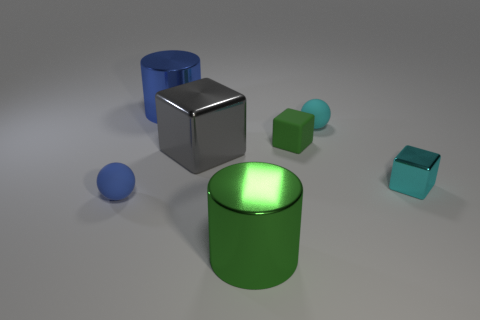Add 1 blue rubber things. How many objects exist? 8 Subtract all brown cubes. Subtract all purple cylinders. How many cubes are left? 3 Subtract all cylinders. How many objects are left? 5 Add 4 cyan metallic objects. How many cyan metallic objects are left? 5 Add 1 tiny cyan rubber things. How many tiny cyan rubber things exist? 2 Subtract 0 purple cylinders. How many objects are left? 7 Subtract all green blocks. Subtract all big cyan rubber objects. How many objects are left? 6 